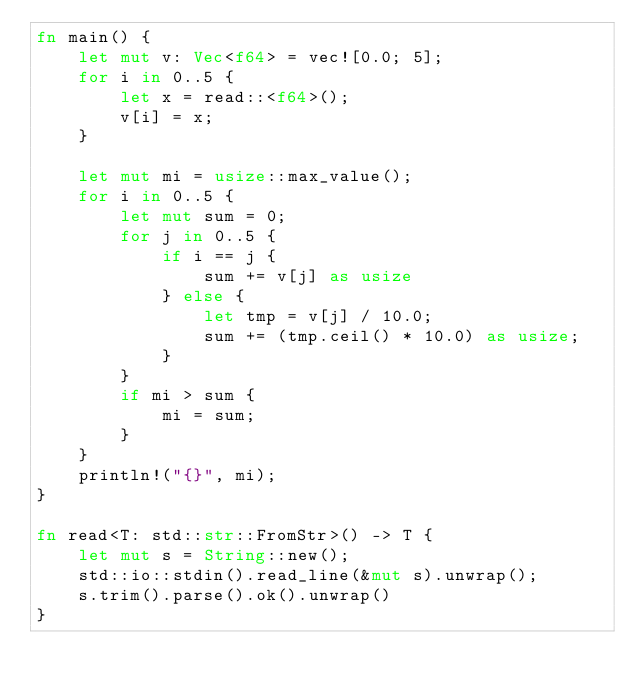Convert code to text. <code><loc_0><loc_0><loc_500><loc_500><_Rust_>fn main() {
    let mut v: Vec<f64> = vec![0.0; 5];
    for i in 0..5 {
        let x = read::<f64>();
        v[i] = x;
    }

    let mut mi = usize::max_value();
    for i in 0..5 {
        let mut sum = 0;
        for j in 0..5 {
            if i == j {
                sum += v[j] as usize
            } else {
                let tmp = v[j] / 10.0;
                sum += (tmp.ceil() * 10.0) as usize;
            }
        }
        if mi > sum {
            mi = sum;
        }
    }
    println!("{}", mi);
}

fn read<T: std::str::FromStr>() -> T {
    let mut s = String::new();
    std::io::stdin().read_line(&mut s).unwrap();
    s.trim().parse().ok().unwrap()
}
</code> 